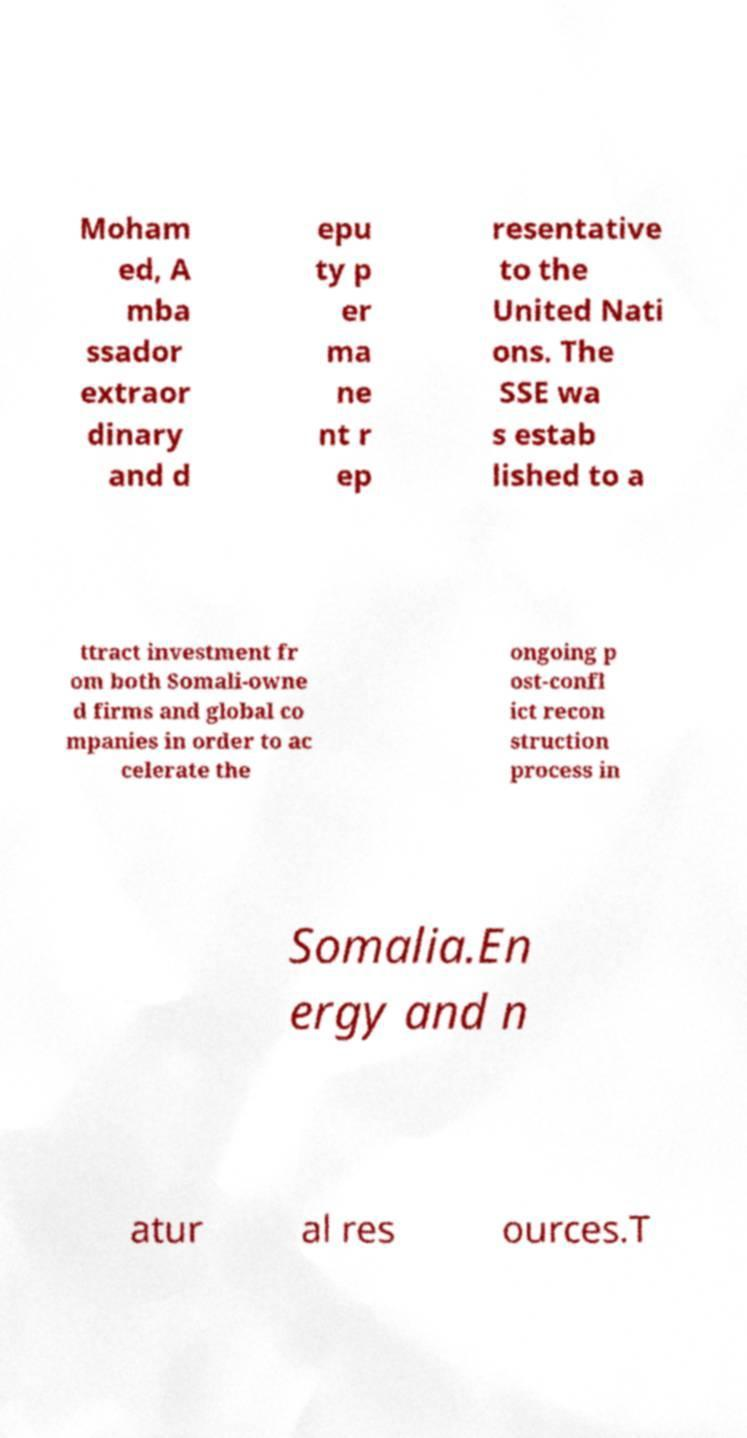Could you assist in decoding the text presented in this image and type it out clearly? Moham ed, A mba ssador extraor dinary and d epu ty p er ma ne nt r ep resentative to the United Nati ons. The SSE wa s estab lished to a ttract investment fr om both Somali-owne d firms and global co mpanies in order to ac celerate the ongoing p ost-confl ict recon struction process in Somalia.En ergy and n atur al res ources.T 